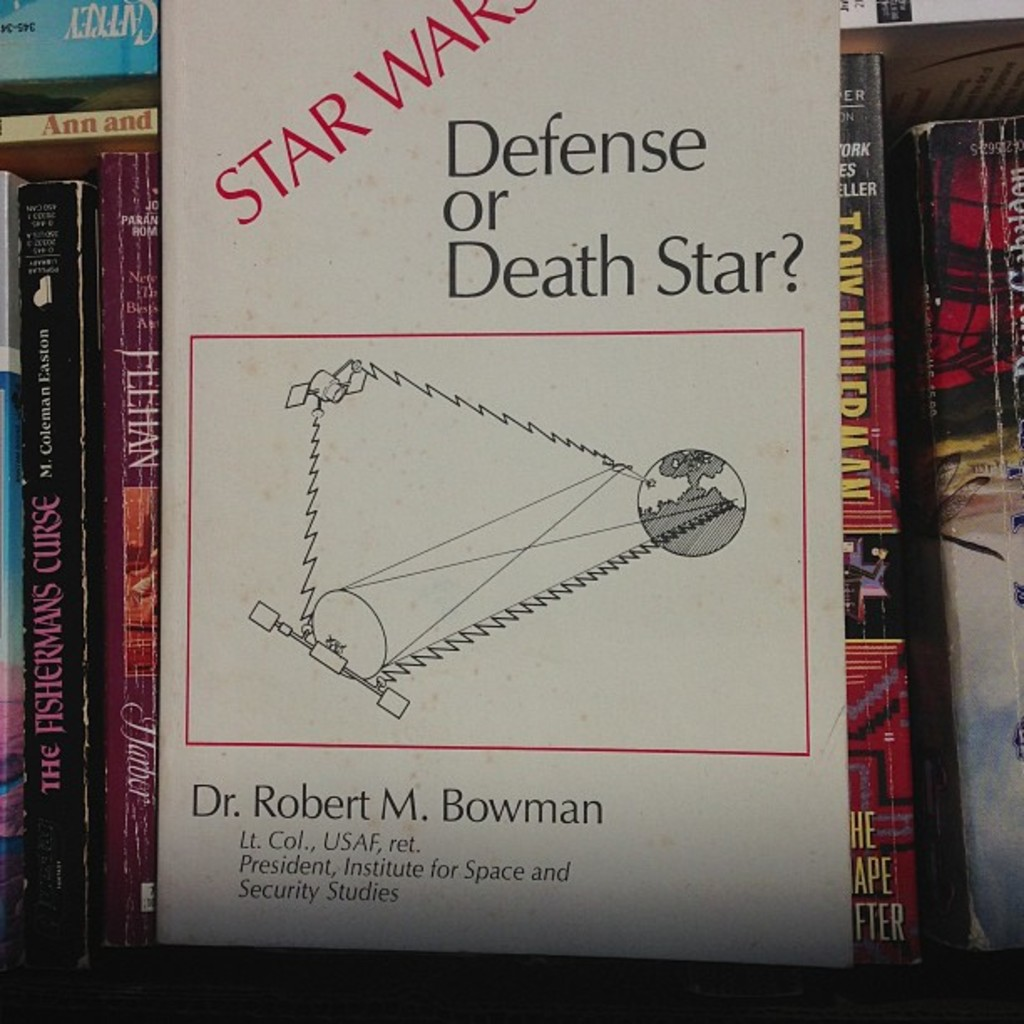Can you describe the main features of this image for me? This image prominently displays the cover of a book titled 'Star Wars: Defense or Death Star?' authored by Dr. Robert M. Bowman, a retired Lieutenant Colonel in the United States Air Force. Utilizing a straightforward cover design, the book features an illustration involving the iconic Death Star from the Star Wars saga, depicted with a trajectory outline leading to a planet, likely emphasizing discussions within the book about space strategy and theoretical military concepts involving superweapons, compared to real-world defense technologies and strategies in space. 